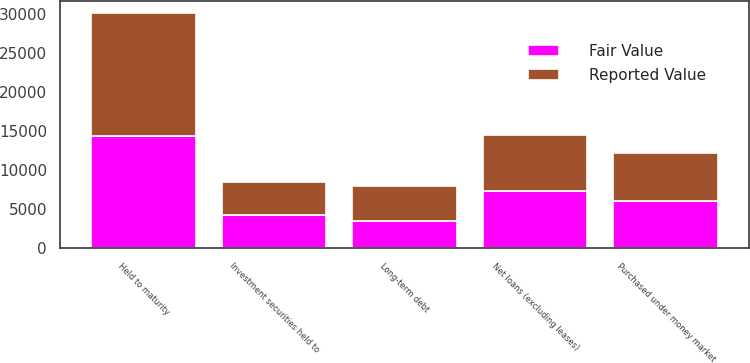Convert chart. <chart><loc_0><loc_0><loc_500><loc_500><stacked_bar_chart><ecel><fcel>Purchased under money market<fcel>Held to maturity<fcel>Net loans (excluding leases)<fcel>Long-term debt<fcel>Investment securities held to<nl><fcel>Reported Value<fcel>6087<fcel>15767<fcel>7269<fcel>4419<fcel>4233<nl><fcel>Fair Value<fcel>6101<fcel>14311<fcel>7269<fcel>3510<fcel>4225<nl></chart> 